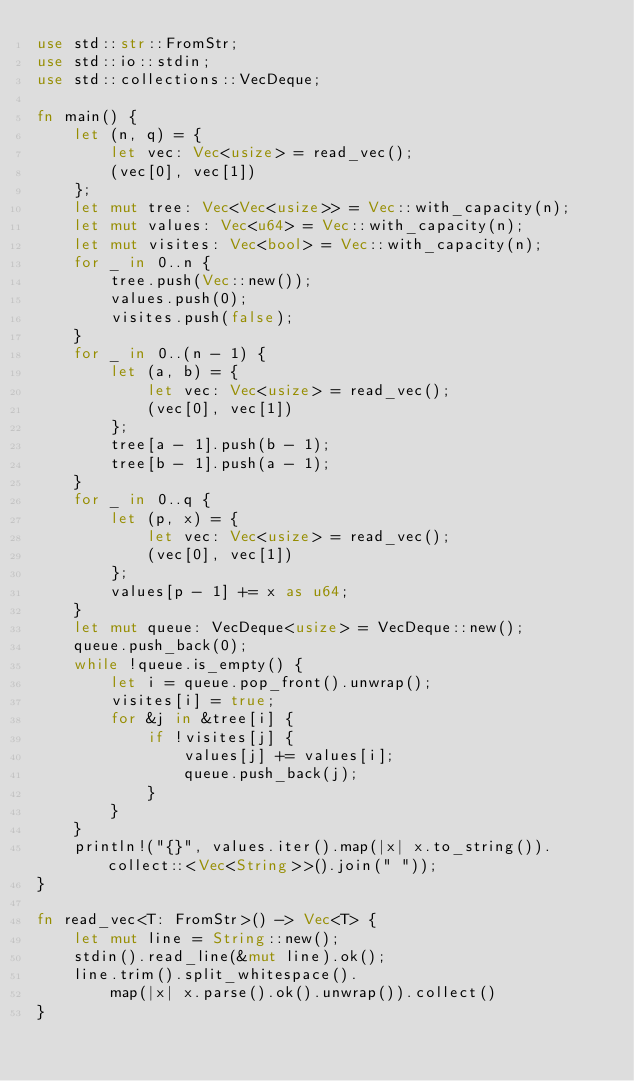Convert code to text. <code><loc_0><loc_0><loc_500><loc_500><_Rust_>use std::str::FromStr;
use std::io::stdin;
use std::collections::VecDeque;

fn main() {
    let (n, q) = {
        let vec: Vec<usize> = read_vec();
        (vec[0], vec[1])
    };
    let mut tree: Vec<Vec<usize>> = Vec::with_capacity(n);
    let mut values: Vec<u64> = Vec::with_capacity(n);
    let mut visites: Vec<bool> = Vec::with_capacity(n);
    for _ in 0..n {
        tree.push(Vec::new());
        values.push(0);
        visites.push(false);
    }
    for _ in 0..(n - 1) {
        let (a, b) = {
            let vec: Vec<usize> = read_vec();
            (vec[0], vec[1])
        };
        tree[a - 1].push(b - 1);
        tree[b - 1].push(a - 1);
    }
    for _ in 0..q {
        let (p, x) = {
            let vec: Vec<usize> = read_vec();
            (vec[0], vec[1])
        };
        values[p - 1] += x as u64;
    }
    let mut queue: VecDeque<usize> = VecDeque::new();
    queue.push_back(0);
    while !queue.is_empty() {
        let i = queue.pop_front().unwrap();
        visites[i] = true;
        for &j in &tree[i] {
            if !visites[j] {
                values[j] += values[i];
                queue.push_back(j);
            }
        }
    }
    println!("{}", values.iter().map(|x| x.to_string()).collect::<Vec<String>>().join(" "));
}

fn read_vec<T: FromStr>() -> Vec<T> {
    let mut line = String::new();
    stdin().read_line(&mut line).ok();
    line.trim().split_whitespace().
        map(|x| x.parse().ok().unwrap()).collect()
}</code> 